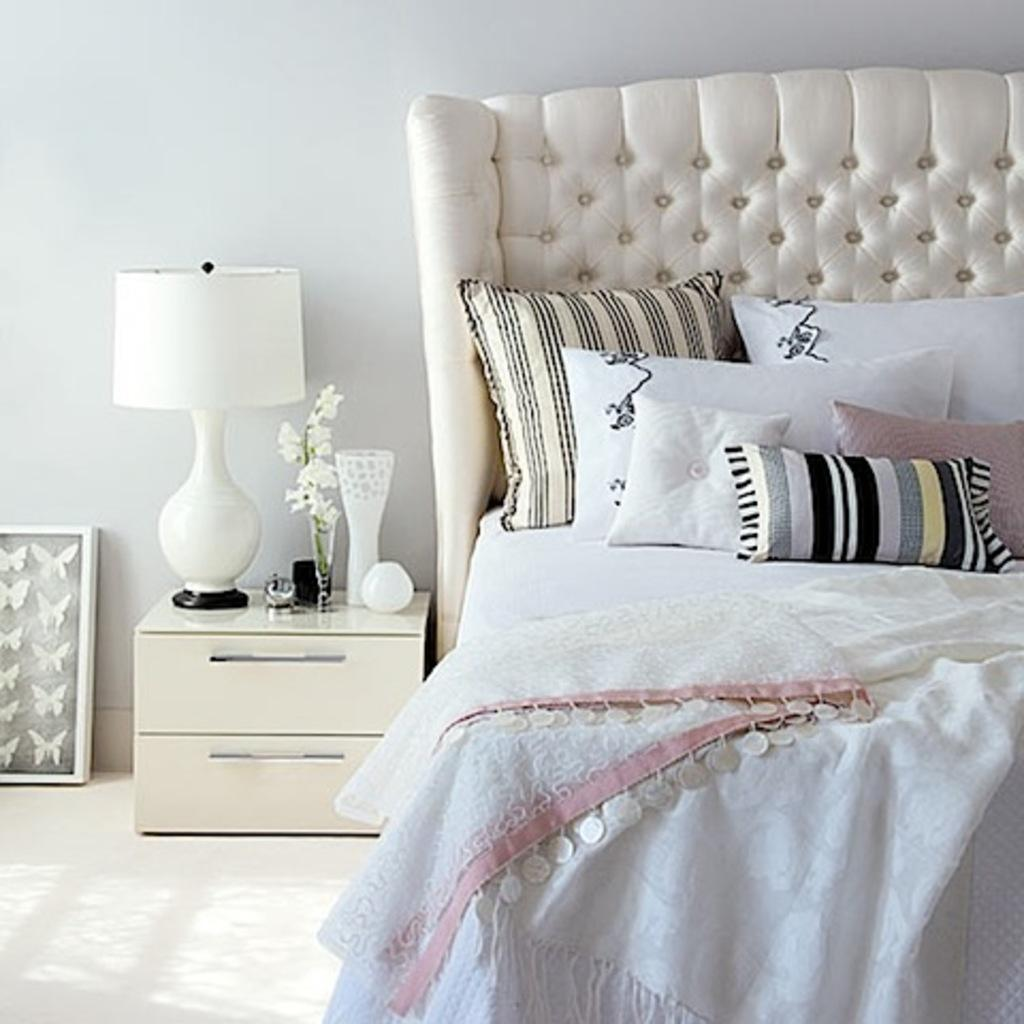What is located on the left side of the image? There is a desk, a lamp, a flower vase, and a frame on the left side of the image. What is the background on the left side of the image? There is a wall on the left side of the image. What is located on the right side of the image? There are pillows, a bed, a blanket, and a wall on the right side of the image. How many fingers can be seen holding the frame in the image? There are no fingers visible in the image, as the frame is not being held by anyone. What type of glue is used to attach the pillows to the bed in the image? There is no glue present in the image, and the pillows are not attached to the bed. 